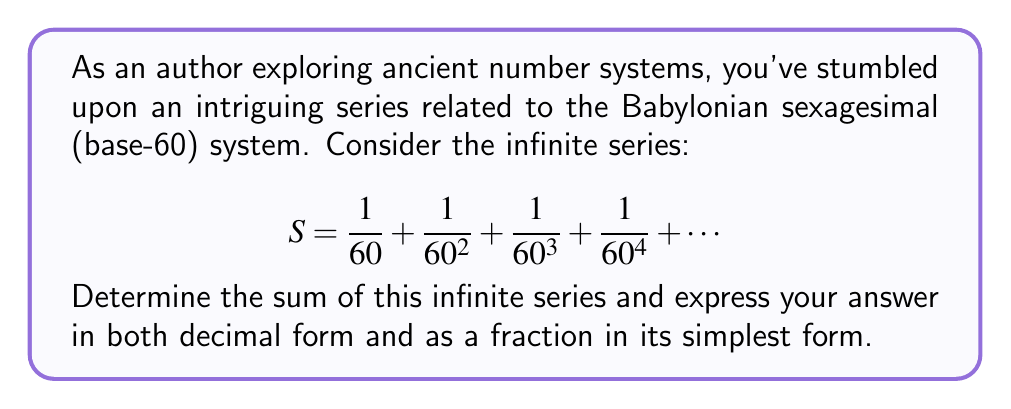Solve this math problem. To solve this problem, we can use the formula for the sum of an infinite geometric series:

$$S_{\infty} = \frac{a}{1-r}$$

Where $a$ is the first term and $r$ is the common ratio between consecutive terms.

In our series:
$a = \frac{1}{60}$ (the first term)
$r = \frac{1}{60}$ (the common ratio)

Substituting these values into the formula:

$$S = \frac{\frac{1}{60}}{1-\frac{1}{60}}$$

Simplifying:
$$S = \frac{\frac{1}{60}}{\frac{59}{60}}$$

$$S = \frac{1}{60} \cdot \frac{60}{59}$$

$$S = \frac{1}{59}$$

To express this as a decimal, we divide 1 by 59:

$$S \approx 0.0169491525423728813559322033898305$$

This decimal repeats infinitely, but we can round it to a reasonable number of decimal places for practical use.
Answer: The sum of the infinite series is $\frac{1}{59}$ or approximately $0.0169491525$ (rounded to 10 decimal places). 